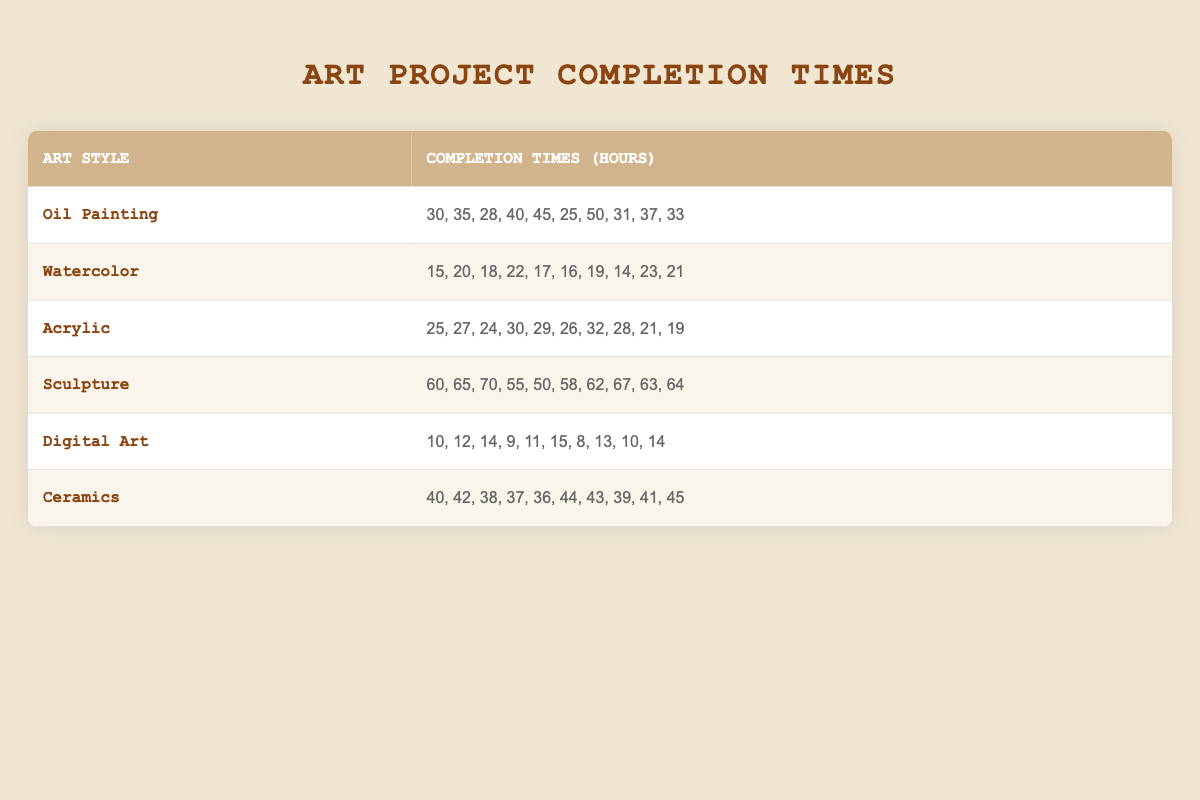What is the highest completion time for Digital Art? The completion times for Digital Art are listed as 10, 12, 14, 9, 11, 15, 8, 13, 10, and 14. The highest value among these is 15.
Answer: 15 What art style has the lowest average completion time? To find the lowest average, we first calculate the average for each art style. For Digital Art: (10 + 12 + 14 + 9 + 11 + 15 + 8 + 13 + 10 + 14) / 10 = 11.6, Watercolor: (15 + 20 + 18 + 22 + 17 + 16 + 19 + 14 + 23 + 21) / 10 = 18.5, Acrylic: (25 + 27 + 24 + 30 + 29 + 26 + 32 + 28 + 21 + 19) / 10 = 25.1, Oil Painting: (30 + 35 + 28 + 40 + 45 + 25 + 50 + 31 + 37 + 33) / 10 = 37.4, Ceramics: (40 + 42 + 38 + 37 + 36 + 44 + 43 + 39 + 41 + 45) / 10 = 40.5, Sculpture: (60 + 65 + 70 + 55 + 50 + 58 + 62 + 67 + 63 + 64) / 10 = 61.5. The lowest average is for Digital Art, thus it has the lowest average completion time.
Answer: Digital Art Is the completion time for Oil Painting higher than that of Acrylic? The highest completion time for Oil Painting is 50 and for Acrylic is 32. Since 50 is greater than 32, the statement is true.
Answer: Yes What is the median completion time for Sculpture? The completion times for Sculpture are arranged as 50, 55, 58, 60, 62, 63, 64, 65, 67, and 70. To find the median, we arrange them in order (already arranged): the median is the average of the 5th and 6th values, which are 62 and 63. So, (62 + 63) / 2 = 62.5.
Answer: 62.5 Which art style has the widest range of completion times? The range is found by subtracting the smallest value from the largest. For Oil Painting, the range is 50 - 25 = 25. For Watercolor, the range is 23 - 14 = 9. For Acrylic, the range is 32 - 19 = 13. For Sculpture, the range is 70 - 50 = 20. For Digital Art, the range is 15 - 8 = 7. For Ceramics, the range is 45 - 36 = 9. The largest range is Oil Painting's 25, indicating it has the widest range of completion times.
Answer: Oil Painting 